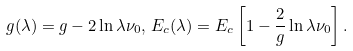Convert formula to latex. <formula><loc_0><loc_0><loc_500><loc_500>g ( \lambda ) = g - 2 \ln \lambda \nu _ { 0 } , \, E _ { c } ( \lambda ) = E _ { c } \left [ 1 - \frac { 2 } { g } \ln \lambda \nu _ { 0 } \right ] .</formula> 